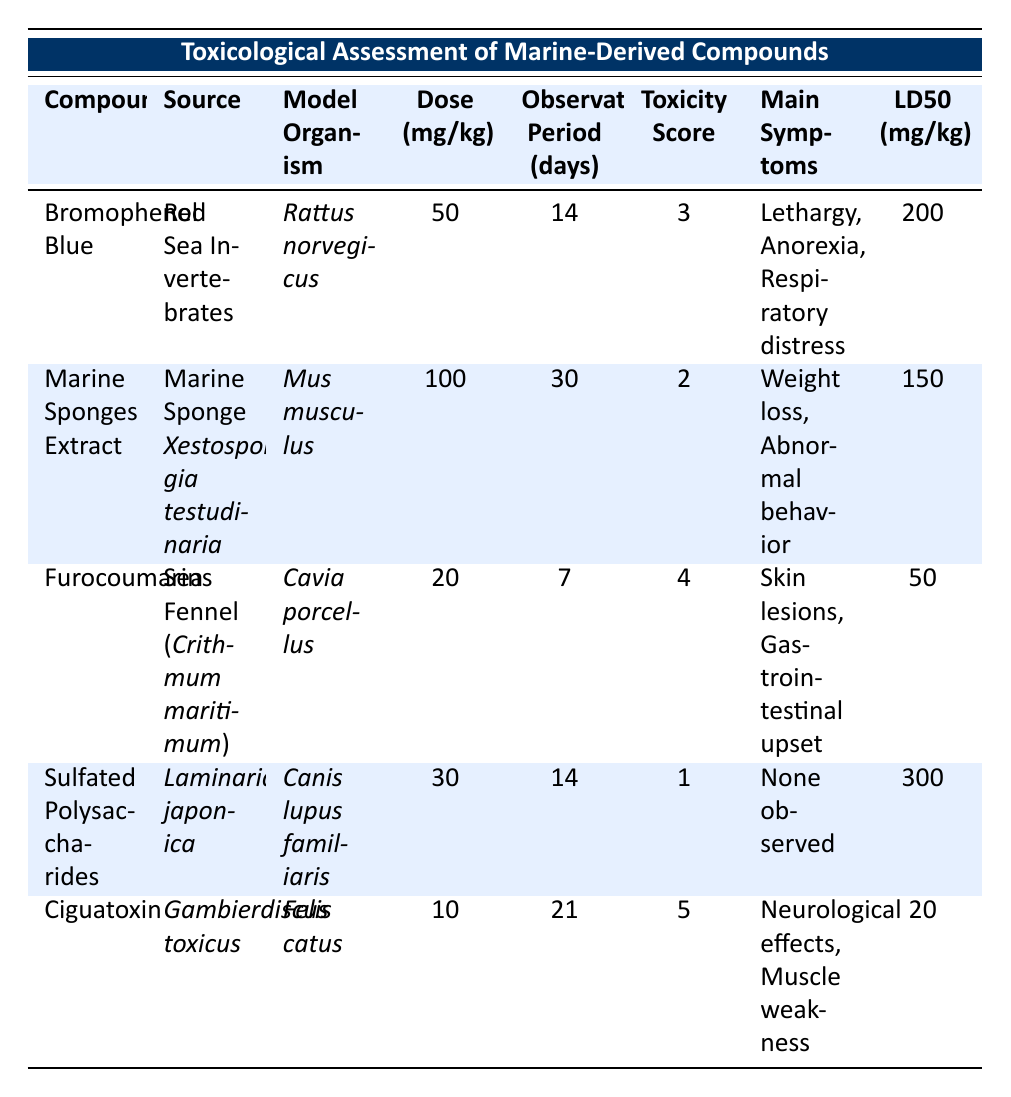What is the Toxicity Score of Ciguatoxin? The Toxicity Score is listed in the row for Ciguatoxin, which states "5."
Answer: 5 Which compound has the highest LD50 value? LD50 values are provided in the last column. They are 200, 150, 50, 300, and 20 for the respective compounds. The highest is 300 for Sulfated Polysaccharides.
Answer: 300 What are the main symptoms observed in the study for Furocoumarins? The main symptoms for Furocoumarins are directly listed in its row, which states "Skin lesions, Gastrointestinal upset."
Answer: Skin lesions, Gastrointestinal upset Is the observation period longer for Marine Sponges Extract than for Ciguatoxin? The observation period for Marine Sponges Extract is 30 days, while for Ciguatoxin, it is 21 days. Since 30 > 21, the answer is yes.
Answer: Yes What is the average dose of the compounds tested in this assessment? The doses are 50, 100, 20, 30, and 10 mg/kg. Adding these together gives 50 + 100 + 20 + 30 + 10 = 210. Dividing by the number of compounds (5), the average dose is 210 / 5 = 42.
Answer: 42 Which compound showed no observed symptoms? In the table, Sulfated Polysaccharides is explicitly noted to have "None observed" as its main symptoms.
Answer: Sulfated Polysaccharides Is there any compound that had a lower LD50 than Ciguatoxin? The LD50 of Ciguatoxin is 20 mg/kg. The LD50 values of the other compounds are 200, 150, 50, and 300. None of these are lower than 20, hence the answer is no.
Answer: No What are the differences in Toxicity Scores between the most and least toxic compounds? The Toxicity Scores are 5 for Ciguatoxin (most toxic) and 1 for Sulfated Polysaccharides (least toxic). The difference is calculated as 5 - 1 = 4.
Answer: 4 